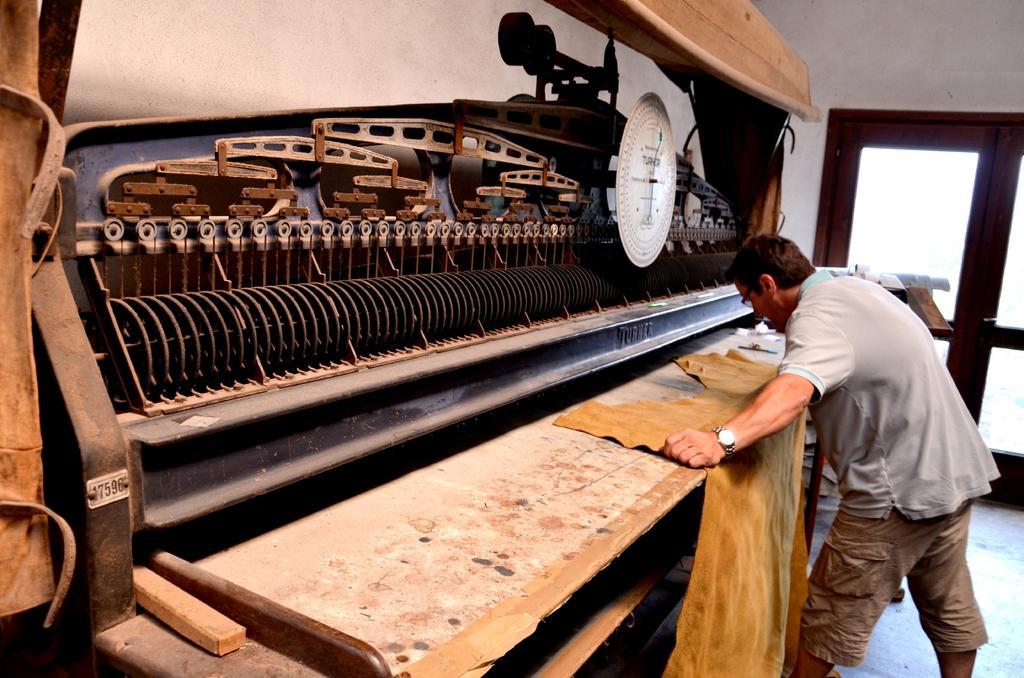In one or two sentences, can you explain what this image depicts? In the image we can see a man standing, wearing clothes, wrist watch and spectacles and he is holding a cloth in his hand. Here we can see a metal object, floor and a window. 